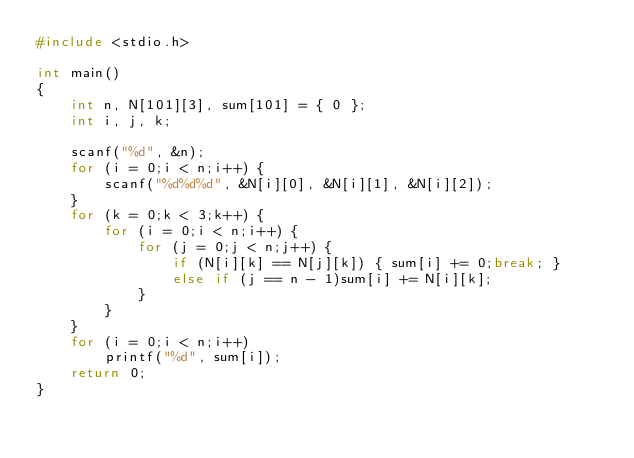<code> <loc_0><loc_0><loc_500><loc_500><_C_>#include <stdio.h>

int main()
{
	int n, N[101][3], sum[101] = { 0 };
	int i, j, k;

	scanf("%d", &n);
	for (i = 0;i < n;i++) {
		scanf("%d%d%d", &N[i][0], &N[i][1], &N[i][2]);
	}
	for (k = 0;k < 3;k++) {
		for (i = 0;i < n;i++) {
			for (j = 0;j < n;j++) {
				if (N[i][k] == N[j][k]) { sum[i] += 0;break; }
				else if (j == n - 1)sum[i] += N[i][k];
			}
		}
	}
	for (i = 0;i < n;i++)
		printf("%d", sum[i]);
	return 0;
}</code> 